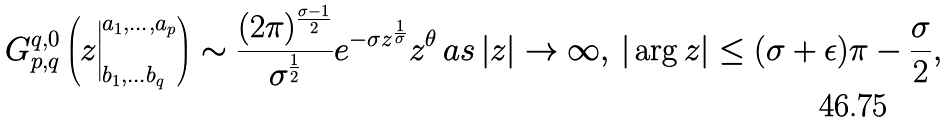Convert formula to latex. <formula><loc_0><loc_0><loc_500><loc_500>G ^ { q , 0 } _ { p , q } \left ( z \Big | ^ { a _ { 1 } , \dots , a _ { p } } _ { b _ { 1 } , \dots b _ { q } } \right ) \sim \frac { ( 2 \pi ) ^ { \frac { \sigma - 1 } { 2 } } } { \sigma ^ { \frac { 1 } { 2 } } } e ^ { - \sigma z ^ { \frac { 1 } { \sigma } } } z ^ { \theta } \, a s \, | z | \rightarrow \infty , \, | \arg z | \leq ( \sigma + \epsilon ) \pi - \frac { \sigma } { 2 } ,</formula> 